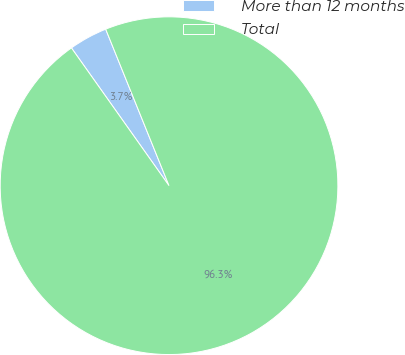Convert chart. <chart><loc_0><loc_0><loc_500><loc_500><pie_chart><fcel>More than 12 months<fcel>Total<nl><fcel>3.69%<fcel>96.31%<nl></chart> 